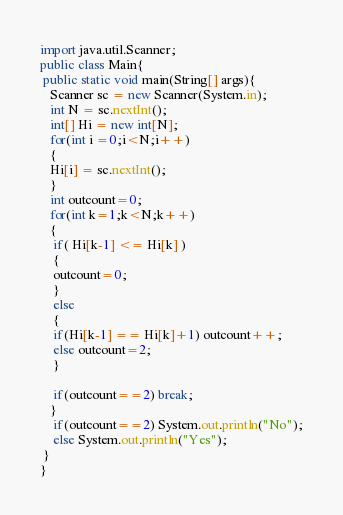<code> <loc_0><loc_0><loc_500><loc_500><_Java_>import java.util.Scanner;
public class Main{
 public static void main(String[] args){
   Scanner sc = new Scanner(System.in);
   int N = sc.nextInt();
   int[] Hi = new int[N];
   for(int i =0;i<N;i++)
   {
   Hi[i] = sc.nextInt();
   }
   int outcount=0;
   for(int k=1;k<N;k++)
   {
    if( Hi[k-1] <= Hi[k] )
    {
    outcount=0;
    }
    else
    {
    if(Hi[k-1] == Hi[k]+1) outcount++;
    else outcount=2;
    }
    
    if(outcount==2) break;
   }
    if(outcount==2) System.out.println("No");
    else System.out.println("Yes");
 }
}</code> 